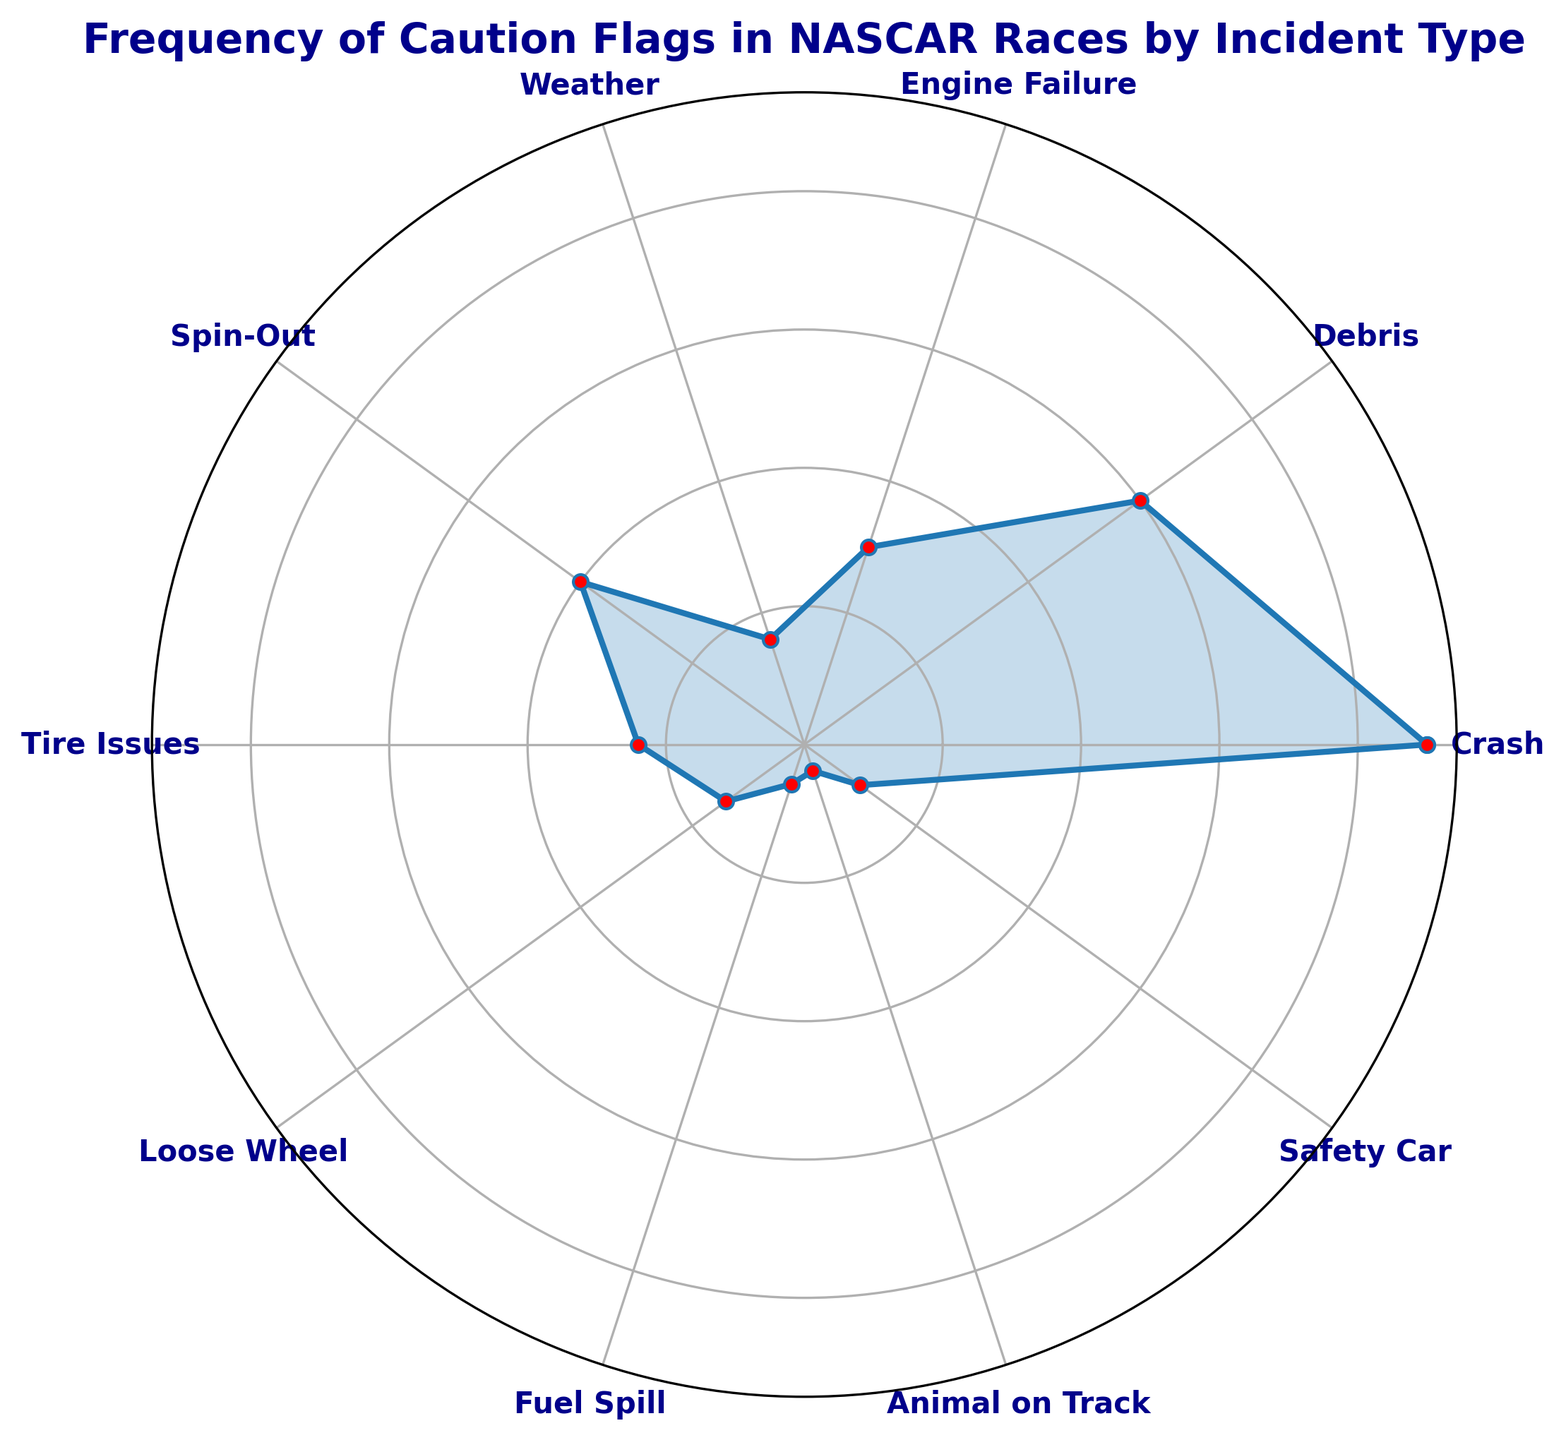What's the most common type of incident that causes caution flags? The plot shows different incidents with varying frequencies represented by the length from the center. The longest plot section corresponds to "Crash" with the highest frequency of 45.
Answer: Crash How many more caution flags are caused by crashes compared to debris? In the plot, "Crash" has a frequency of 45 and "Debris" has a frequency of 30. The difference between them is 45 - 30 = 15.
Answer: 15 What’s the total number of caution flags caused by Tire Issues and Engine Failure combined? The frequency for "Tire Issues" is 12, and for "Engine Failure" is 15. The sum of these frequencies is 12 + 15 = 27.
Answer: 27 Which incident type causes the least number of caution flags? The plot shows "Animal on Track" with the shortest section, indicating it has the lowest frequency of 2.
Answer: Animal on Track What's the difference in frequency between Spin-Outs and Unsafe Car conditions? According to the plot, "Spin-Out" has a frequency of 20, and "Safety Car" has a frequency of 5. The difference is 20 - 5 = 15.
Answer: 15 Which incidents have frequencies greater than 10 but less than 20? The plot shows that "Spin-Out" has a frequency of 20, "Engine Failure" has 15, "Tire Issues" has 12, and "Loose Wheel" has 7. The frequencies greater than 10 but less than 20 are from "Engine Failure" and "Tire Issues."
Answer: Engine Failure, Tire Issues How many incidents have a frequency greater than 25? By examining the plot, "Crash" (45) and "Debris" (30) are the only incidents with frequencies greater than 25.
Answer: 2 What is the average frequency of incidents related to caution flags? Summing up the frequencies: 45 (Crash) + 30 (Debris) + 15 (Engine Failure) + 8 (Weather) + 20 (Spin-Out) + 12 (Tire Issues) + 7 (Loose Wheel) + 3 (Fuel Spill) + 2 (Animal on Track) + 5 (Safety Car) = 147. There are 10 incidents, so the average is 147/10 = 14.7.
Answer: 14.7 